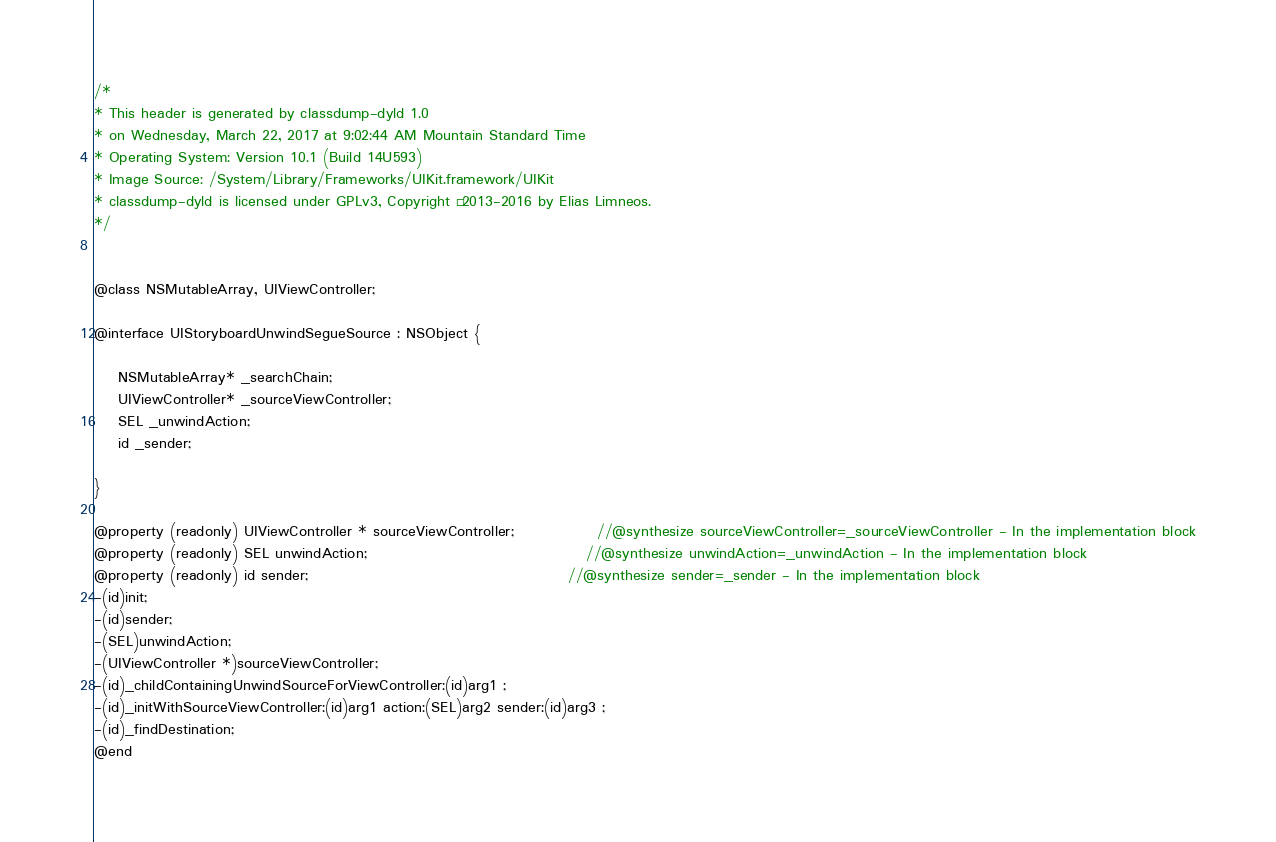<code> <loc_0><loc_0><loc_500><loc_500><_C_>/*
* This header is generated by classdump-dyld 1.0
* on Wednesday, March 22, 2017 at 9:02:44 AM Mountain Standard Time
* Operating System: Version 10.1 (Build 14U593)
* Image Source: /System/Library/Frameworks/UIKit.framework/UIKit
* classdump-dyld is licensed under GPLv3, Copyright © 2013-2016 by Elias Limneos.
*/


@class NSMutableArray, UIViewController;

@interface UIStoryboardUnwindSegueSource : NSObject {

	NSMutableArray* _searchChain;
	UIViewController* _sourceViewController;
	SEL _unwindAction;
	id _sender;

}

@property (readonly) UIViewController * sourceViewController;              //@synthesize sourceViewController=_sourceViewController - In the implementation block
@property (readonly) SEL unwindAction;                                     //@synthesize unwindAction=_unwindAction - In the implementation block
@property (readonly) id sender;                                            //@synthesize sender=_sender - In the implementation block
-(id)init;
-(id)sender;
-(SEL)unwindAction;
-(UIViewController *)sourceViewController;
-(id)_childContainingUnwindSourceForViewController:(id)arg1 ;
-(id)_initWithSourceViewController:(id)arg1 action:(SEL)arg2 sender:(id)arg3 ;
-(id)_findDestination;
@end

</code> 